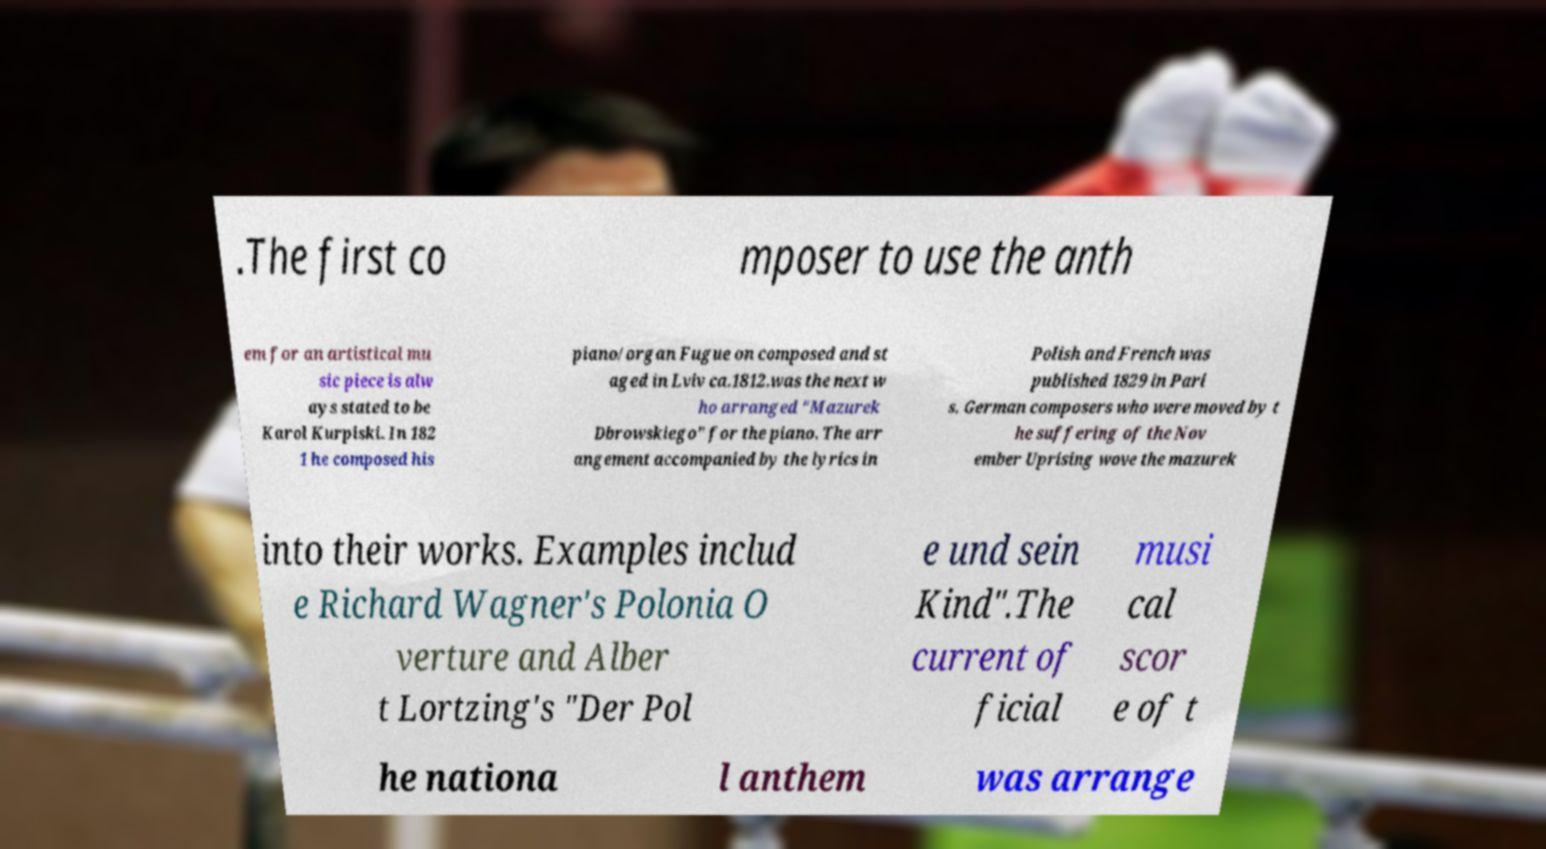What messages or text are displayed in this image? I need them in a readable, typed format. .The first co mposer to use the anth em for an artistical mu sic piece is alw ays stated to be Karol Kurpiski. In 182 1 he composed his piano/organ Fugue on composed and st aged in Lviv ca.1812.was the next w ho arranged "Mazurek Dbrowskiego" for the piano. The arr angement accompanied by the lyrics in Polish and French was published 1829 in Pari s. German composers who were moved by t he suffering of the Nov ember Uprising wove the mazurek into their works. Examples includ e Richard Wagner's Polonia O verture and Alber t Lortzing's "Der Pol e und sein Kind".The current of ficial musi cal scor e of t he nationa l anthem was arrange 